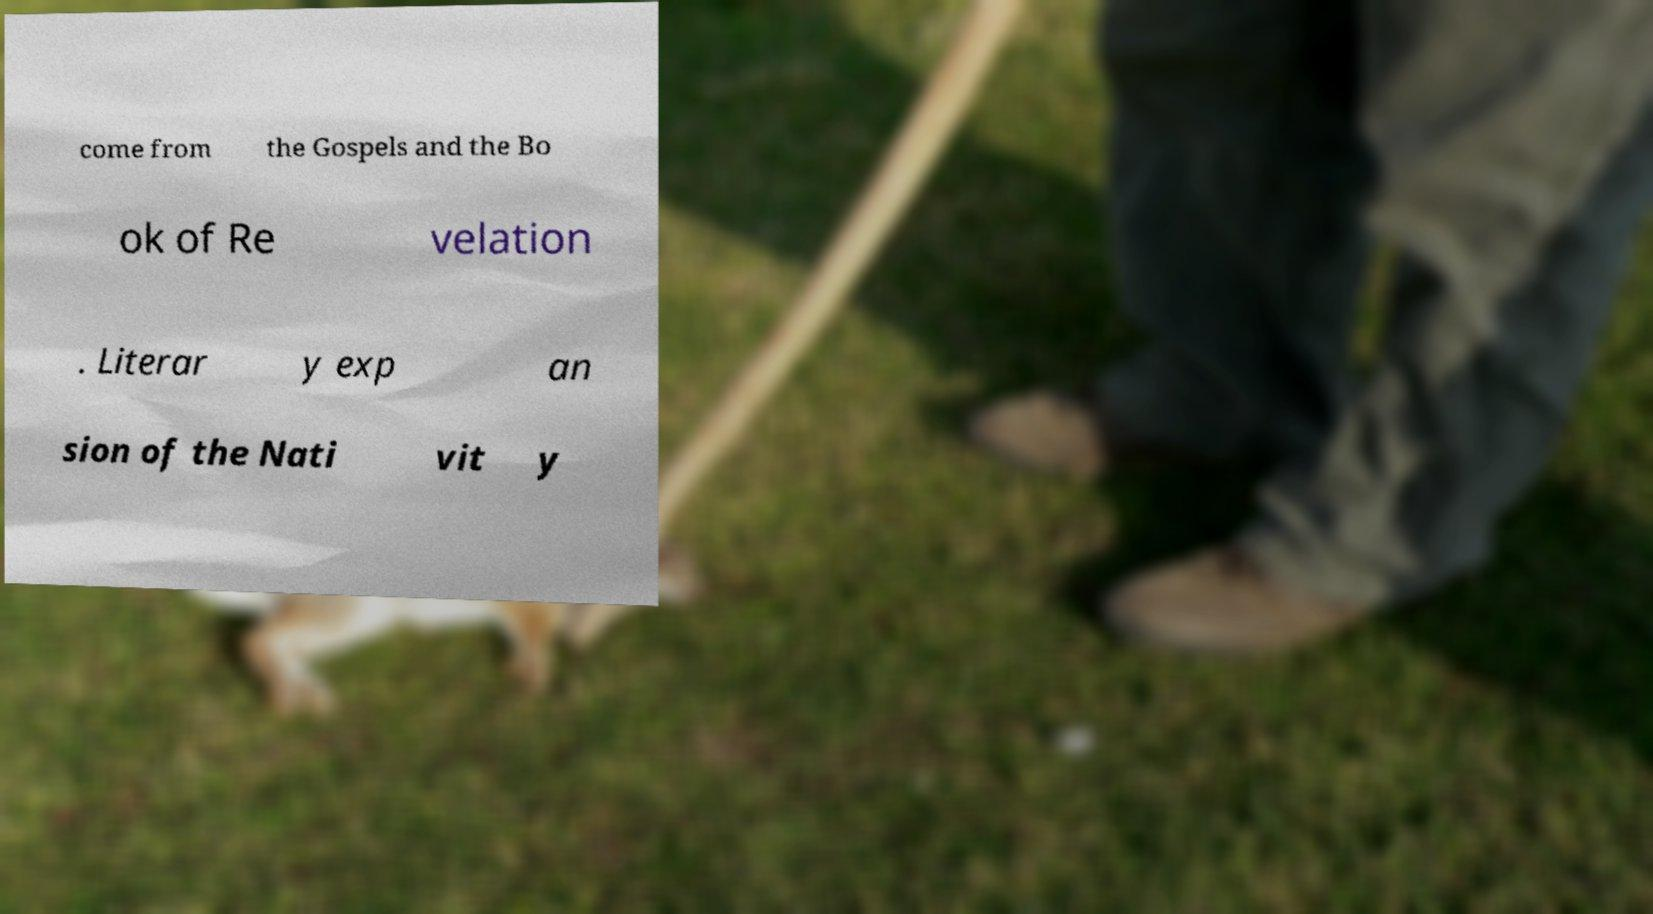Please read and relay the text visible in this image. What does it say? come from the Gospels and the Bo ok of Re velation . Literar y exp an sion of the Nati vit y 